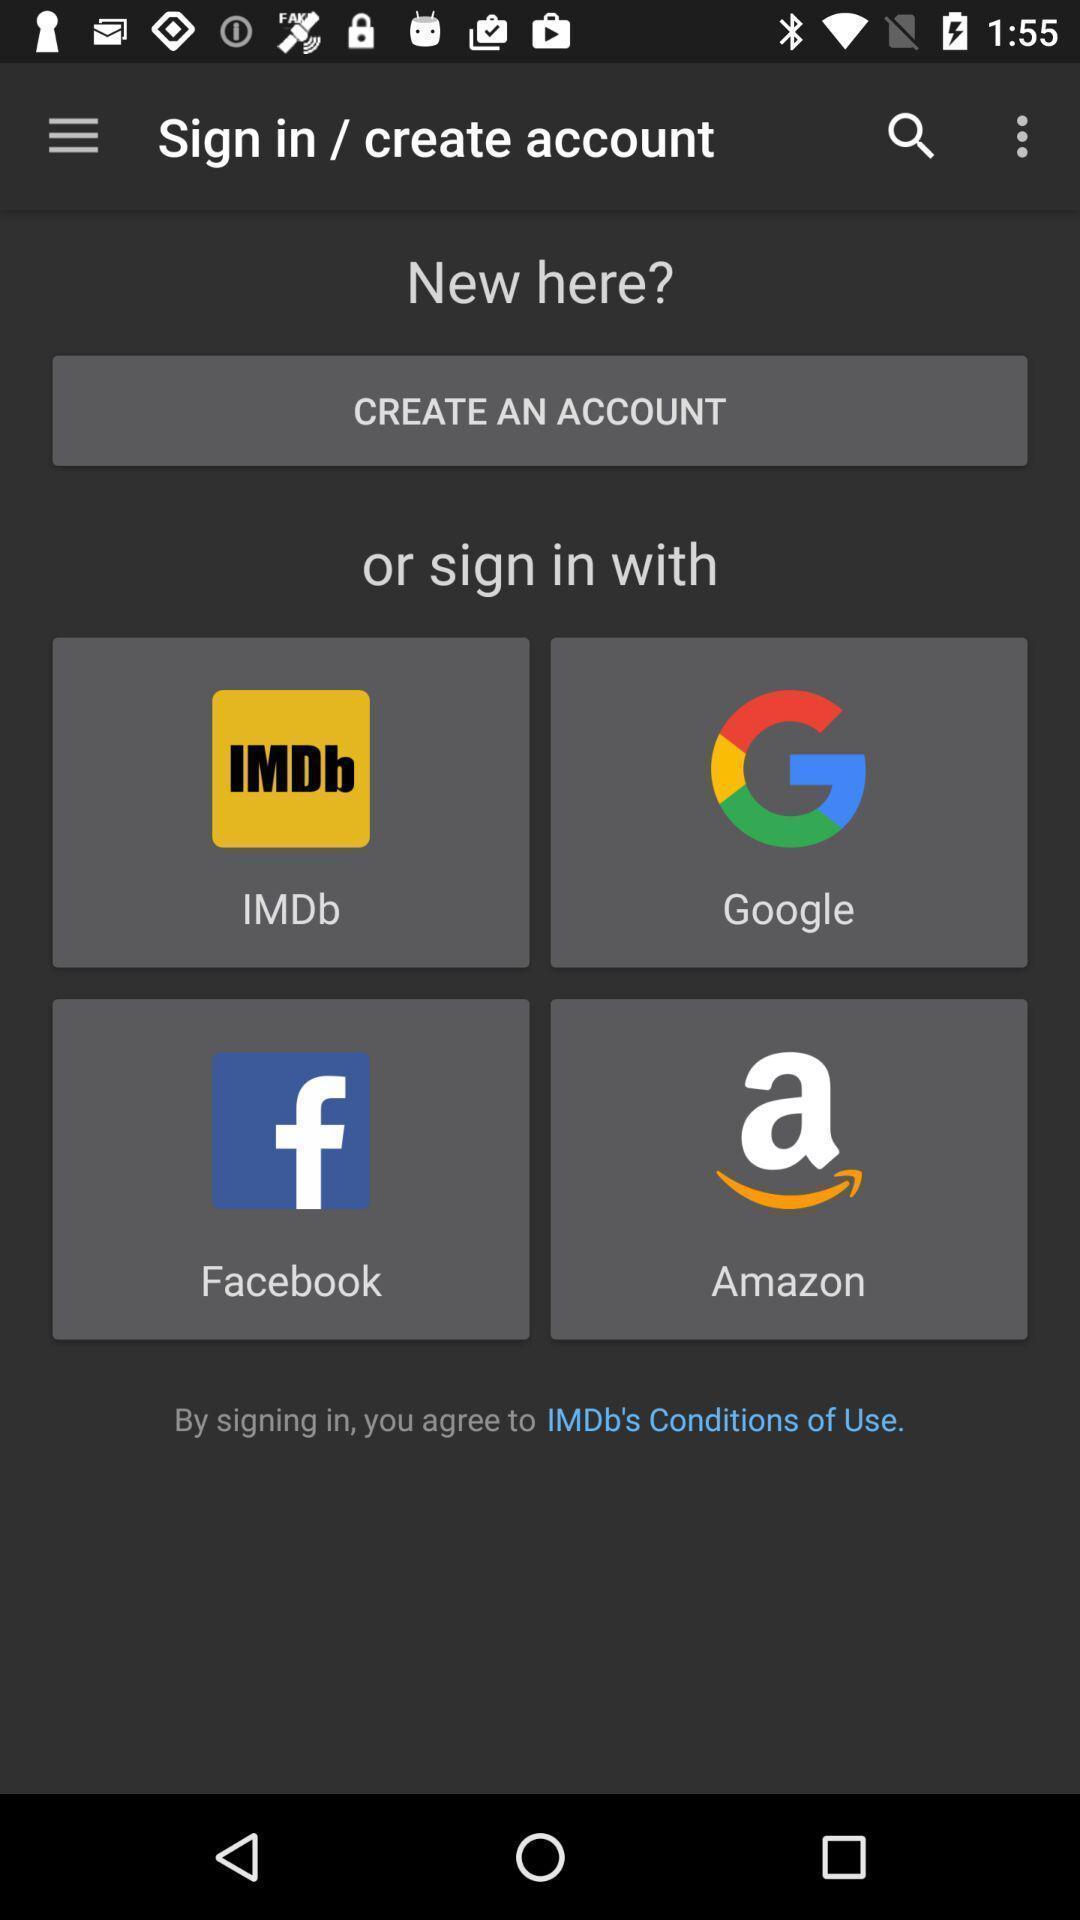Give me a summary of this screen capture. Starting page of application through different credentials. 